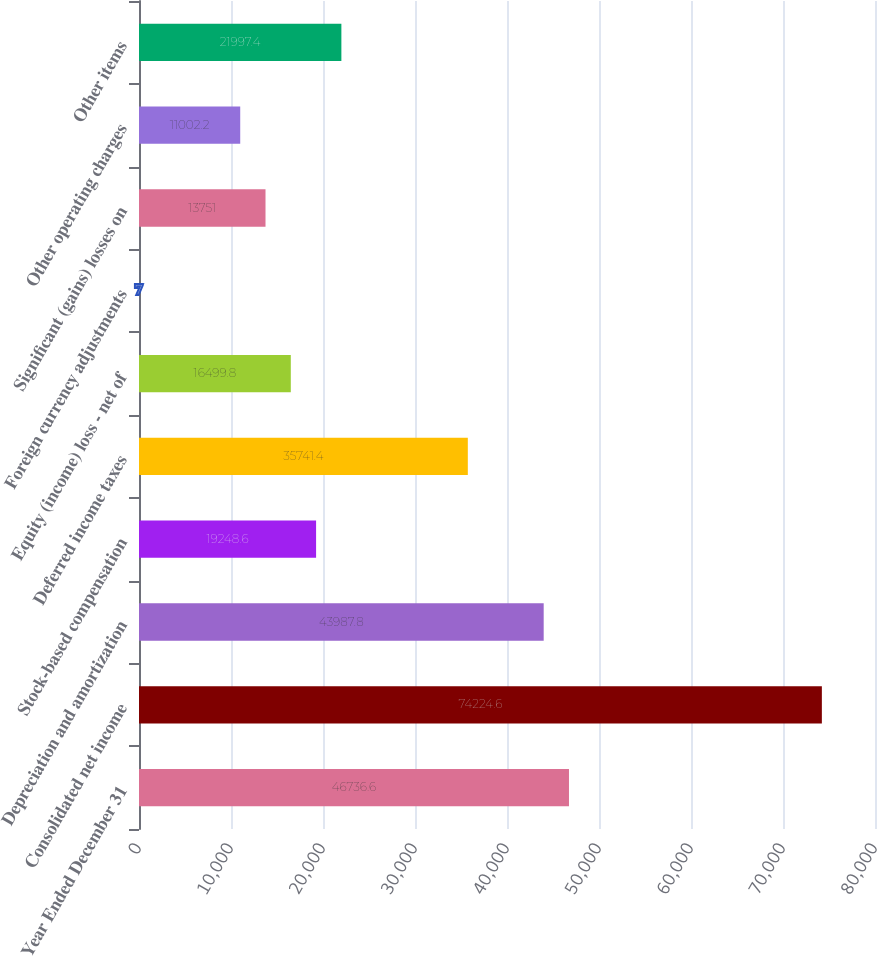<chart> <loc_0><loc_0><loc_500><loc_500><bar_chart><fcel>Year Ended December 31<fcel>Consolidated net income<fcel>Depreciation and amortization<fcel>Stock-based compensation<fcel>Deferred income taxes<fcel>Equity (income) loss - net of<fcel>Foreign currency adjustments<fcel>Significant (gains) losses on<fcel>Other operating charges<fcel>Other items<nl><fcel>46736.6<fcel>74224.6<fcel>43987.8<fcel>19248.6<fcel>35741.4<fcel>16499.8<fcel>7<fcel>13751<fcel>11002.2<fcel>21997.4<nl></chart> 